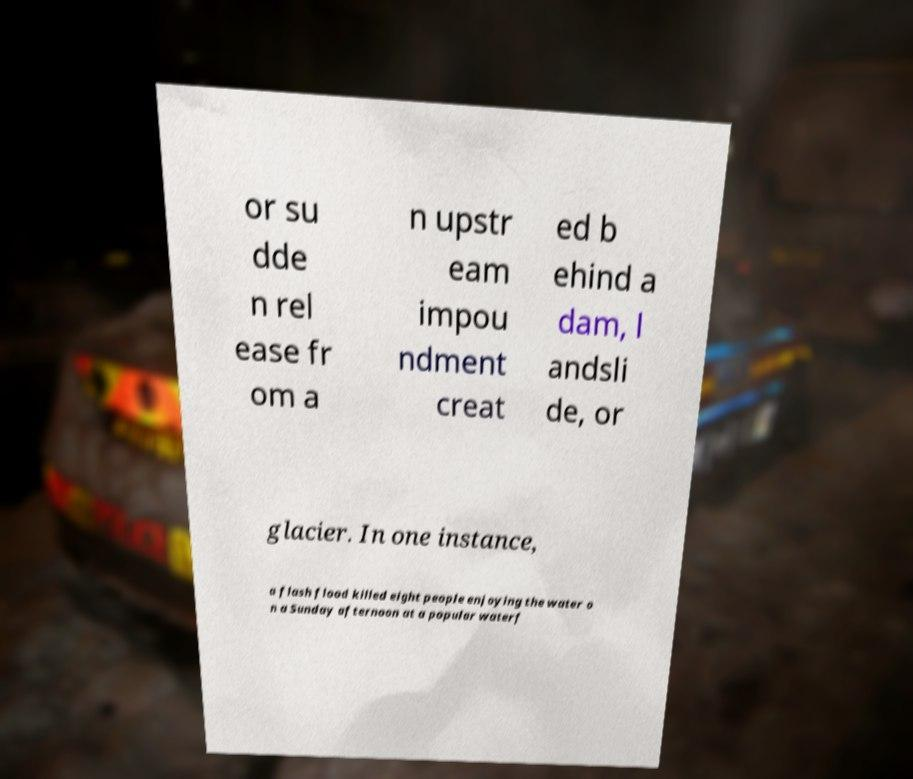I need the written content from this picture converted into text. Can you do that? or su dde n rel ease fr om a n upstr eam impou ndment creat ed b ehind a dam, l andsli de, or glacier. In one instance, a flash flood killed eight people enjoying the water o n a Sunday afternoon at a popular waterf 